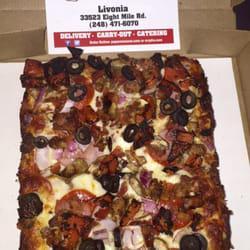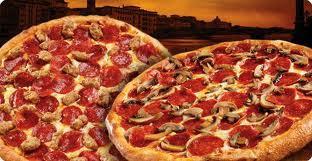The first image is the image on the left, the second image is the image on the right. Assess this claim about the two images: "One of the pizzas has mushrooms on top of the pepperoni toppings.". Correct or not? Answer yes or no. Yes. The first image is the image on the left, the second image is the image on the right. Evaluate the accuracy of this statement regarding the images: "All pizzas are round and no individual pizzas have different toppings on different sides.". Is it true? Answer yes or no. No. 